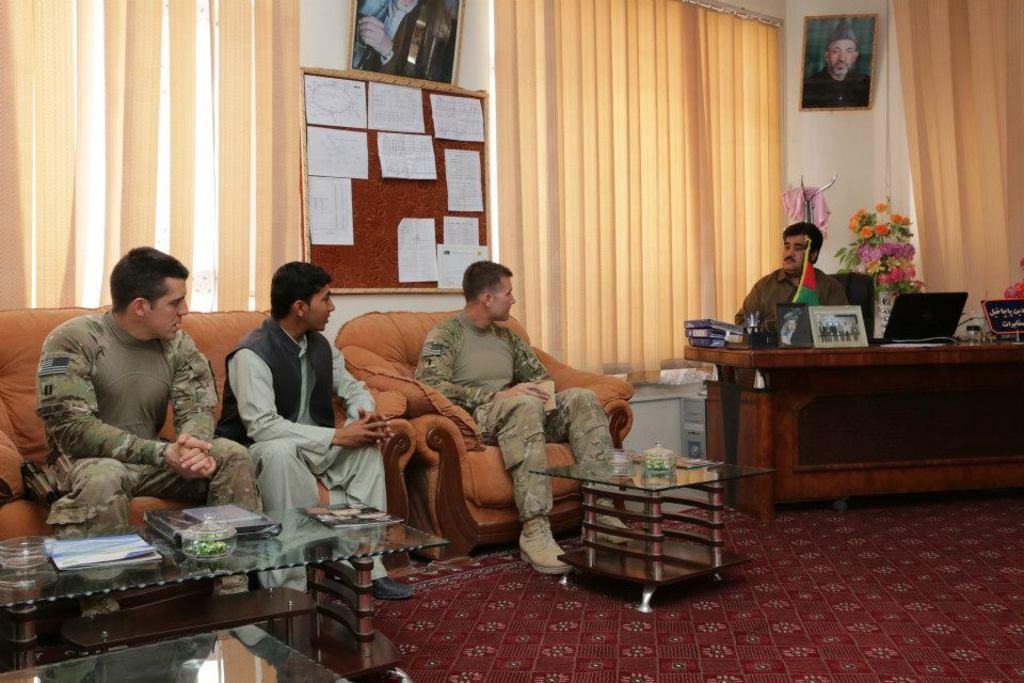How many people are seated in the image? There are four people seated in the image. What are the people seated on? The people are seated on chairs. What can be seen on the table in the image? There is a laptop, a flag, and a photo frame on the table. What type of window treatment is visible in the image? There are blinds visible in the image. Can you describe the development of the wrist in the image? There is no development of the wrist or any body part mentioned in the image; it only features people seated on chairs, a table with various items, and blinds. 